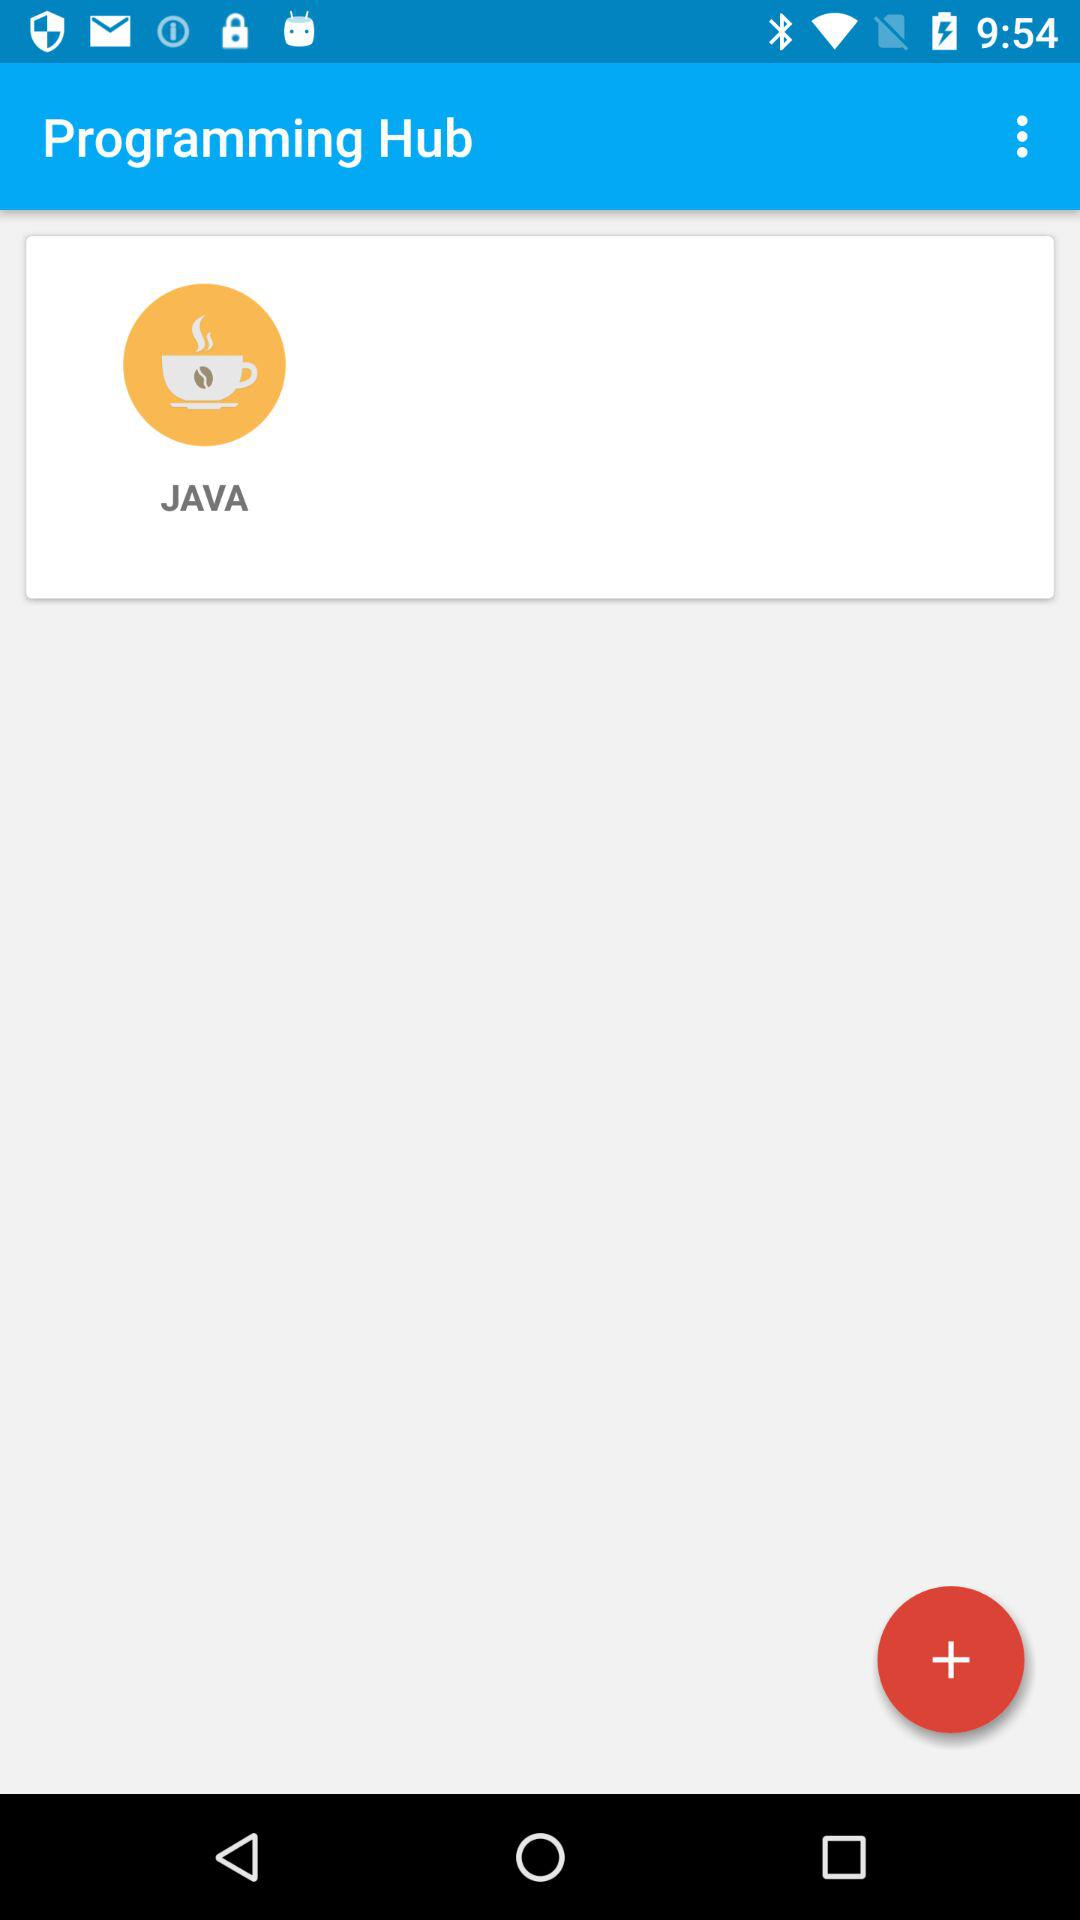What is the name of the application? The name of the application is "Programming Hub". 